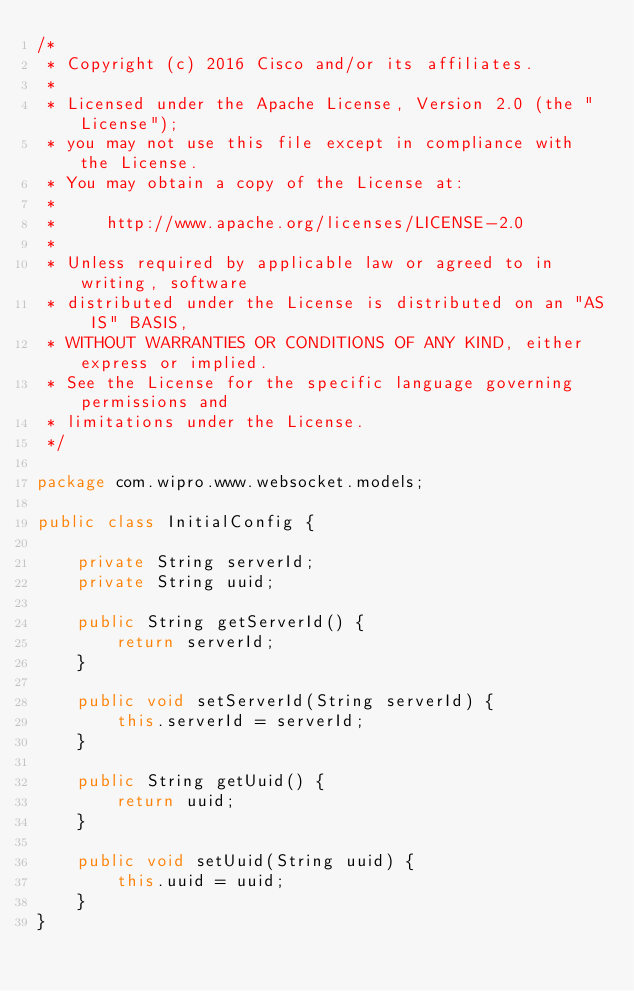<code> <loc_0><loc_0><loc_500><loc_500><_Java_>/*
 * Copyright (c) 2016 Cisco and/or its affiliates.
 *
 * Licensed under the Apache License, Version 2.0 (the "License");
 * you may not use this file except in compliance with the License.
 * You may obtain a copy of the License at:
 *
 *     http://www.apache.org/licenses/LICENSE-2.0
 *
 * Unless required by applicable law or agreed to in writing, software
 * distributed under the License is distributed on an "AS IS" BASIS,
 * WITHOUT WARRANTIES OR CONDITIONS OF ANY KIND, either express or implied.
 * See the License for the specific language governing permissions and
 * limitations under the License.
 */

package com.wipro.www.websocket.models;

public class InitialConfig {

    private String serverId;
    private String uuid;

    public String getServerId() {
        return serverId;
    }

    public void setServerId(String serverId) {
        this.serverId = serverId;
    }

    public String getUuid() {
        return uuid;
    }

    public void setUuid(String uuid) {
        this.uuid = uuid;
    }
}
</code> 